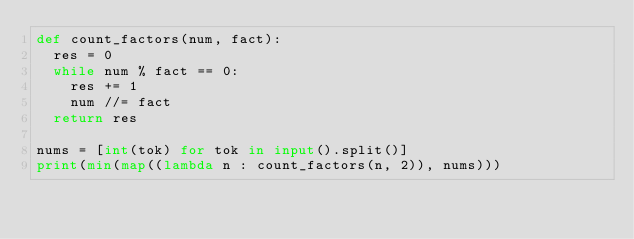Convert code to text. <code><loc_0><loc_0><loc_500><loc_500><_Python_>def count_factors(num, fact):
  res = 0
  while num % fact == 0:
    res += 1
    num //= fact
  return res

nums = [int(tok) for tok in input().split()]
print(min(map((lambda n : count_factors(n, 2)), nums)))</code> 